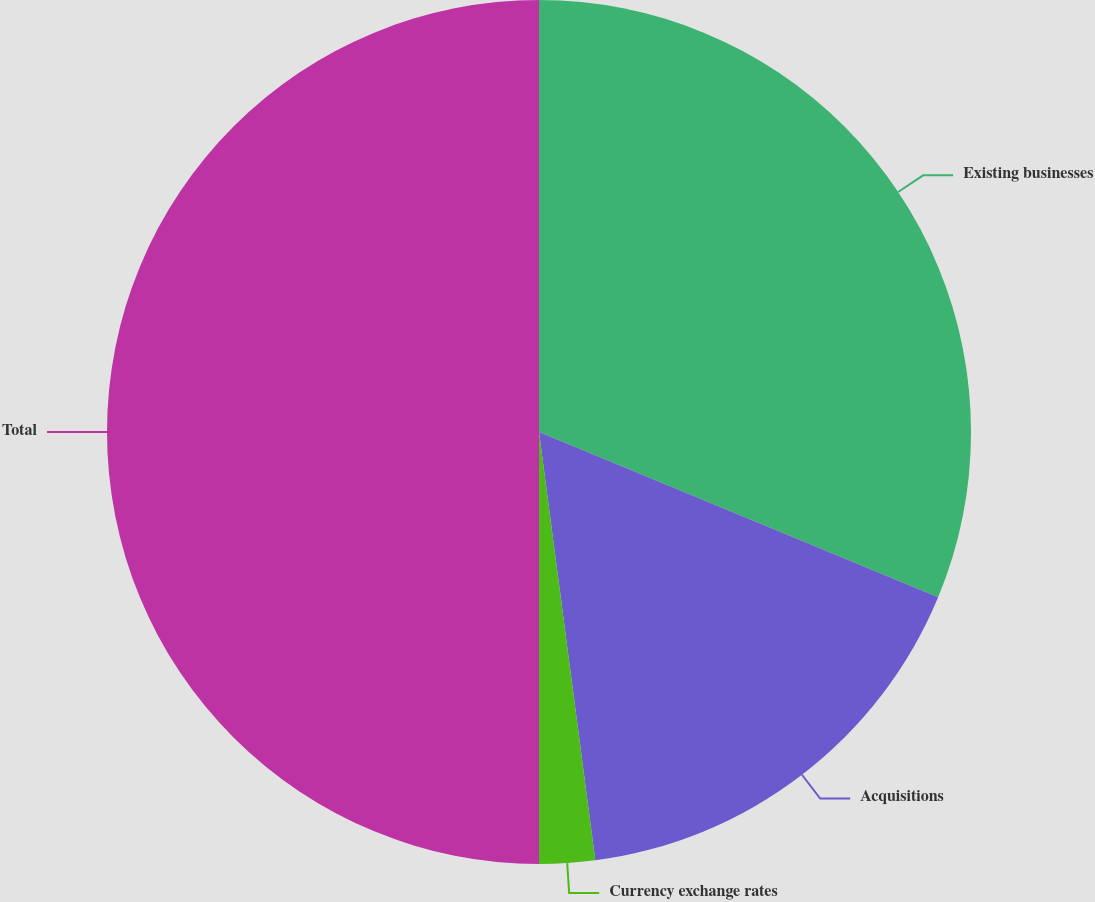Convert chart to OTSL. <chart><loc_0><loc_0><loc_500><loc_500><pie_chart><fcel>Existing businesses<fcel>Acquisitions<fcel>Currency exchange rates<fcel>Total<nl><fcel>31.25%<fcel>16.67%<fcel>2.08%<fcel>50.0%<nl></chart> 